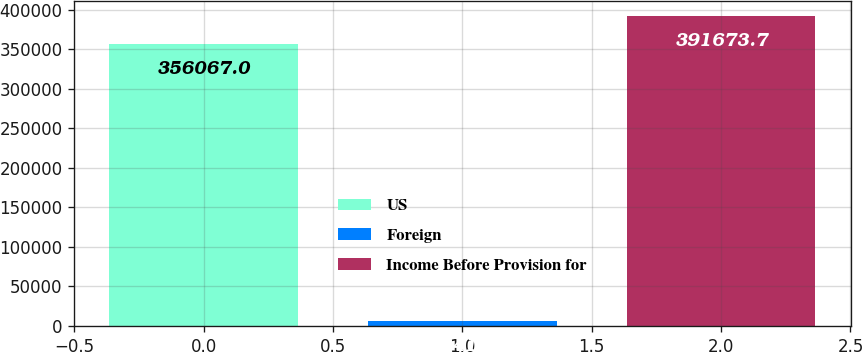Convert chart to OTSL. <chart><loc_0><loc_0><loc_500><loc_500><bar_chart><fcel>US<fcel>Foreign<fcel>Income Before Provision for<nl><fcel>356067<fcel>5841<fcel>391674<nl></chart> 